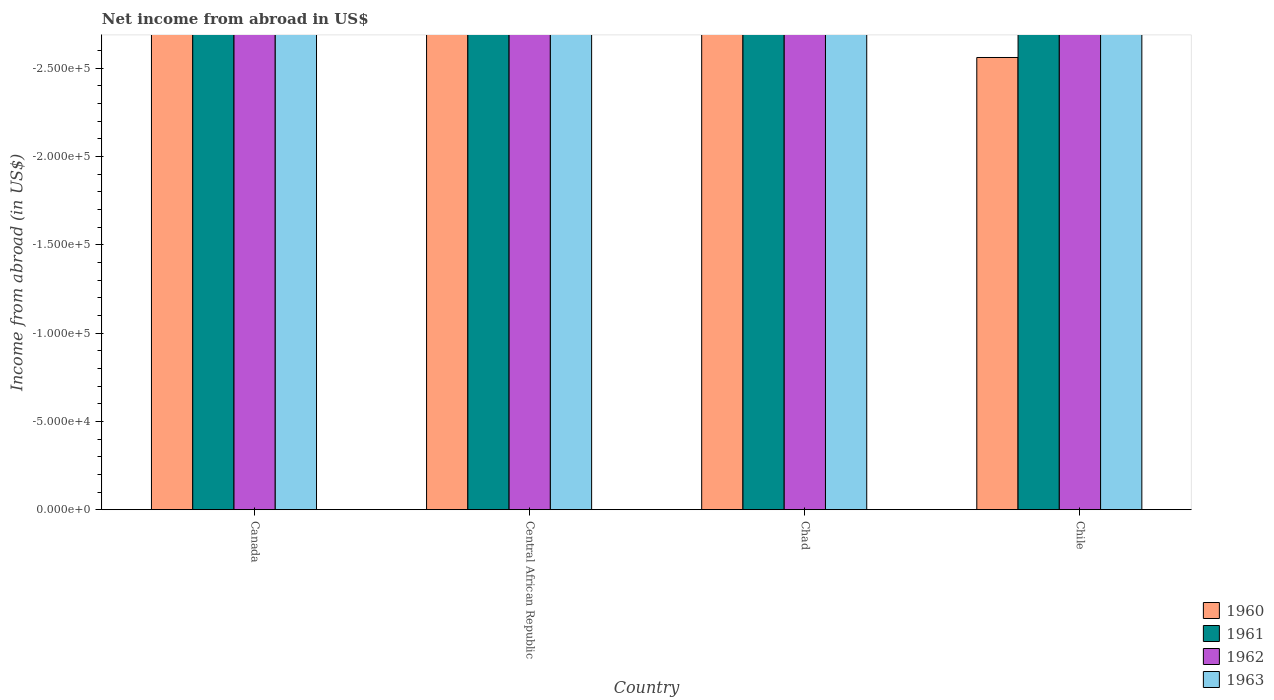Are the number of bars per tick equal to the number of legend labels?
Your response must be concise. No. Are the number of bars on each tick of the X-axis equal?
Keep it short and to the point. Yes. How many bars are there on the 1st tick from the right?
Give a very brief answer. 0. What is the label of the 4th group of bars from the left?
Ensure brevity in your answer.  Chile. In how many cases, is the number of bars for a given country not equal to the number of legend labels?
Offer a terse response. 4. What is the net income from abroad in 1960 in Chad?
Offer a very short reply. 0. What is the difference between the net income from abroad in 1960 in Chile and the net income from abroad in 1963 in Canada?
Provide a short and direct response. 0. What is the average net income from abroad in 1962 per country?
Offer a terse response. 0. In how many countries, is the net income from abroad in 1961 greater than the average net income from abroad in 1961 taken over all countries?
Your response must be concise. 0. Is it the case that in every country, the sum of the net income from abroad in 1963 and net income from abroad in 1961 is greater than the sum of net income from abroad in 1960 and net income from abroad in 1962?
Keep it short and to the point. No. How many bars are there?
Give a very brief answer. 0. What is the difference between two consecutive major ticks on the Y-axis?
Keep it short and to the point. 5.00e+04. How are the legend labels stacked?
Give a very brief answer. Vertical. What is the title of the graph?
Your answer should be compact. Net income from abroad in US$. Does "2005" appear as one of the legend labels in the graph?
Give a very brief answer. No. What is the label or title of the X-axis?
Provide a succinct answer. Country. What is the label or title of the Y-axis?
Ensure brevity in your answer.  Income from abroad (in US$). What is the Income from abroad (in US$) in 1962 in Canada?
Provide a succinct answer. 0. What is the Income from abroad (in US$) of 1961 in Central African Republic?
Offer a very short reply. 0. What is the Income from abroad (in US$) in 1962 in Central African Republic?
Provide a short and direct response. 0. What is the Income from abroad (in US$) in 1963 in Central African Republic?
Provide a succinct answer. 0. What is the Income from abroad (in US$) of 1960 in Chad?
Make the answer very short. 0. What is the Income from abroad (in US$) of 1961 in Chad?
Keep it short and to the point. 0. What is the Income from abroad (in US$) in 1963 in Chad?
Offer a very short reply. 0. What is the Income from abroad (in US$) of 1961 in Chile?
Make the answer very short. 0. What is the Income from abroad (in US$) in 1962 in Chile?
Offer a terse response. 0. What is the Income from abroad (in US$) in 1963 in Chile?
Make the answer very short. 0. What is the total Income from abroad (in US$) in 1960 in the graph?
Your answer should be very brief. 0. What is the total Income from abroad (in US$) in 1961 in the graph?
Ensure brevity in your answer.  0. What is the average Income from abroad (in US$) of 1960 per country?
Make the answer very short. 0. 